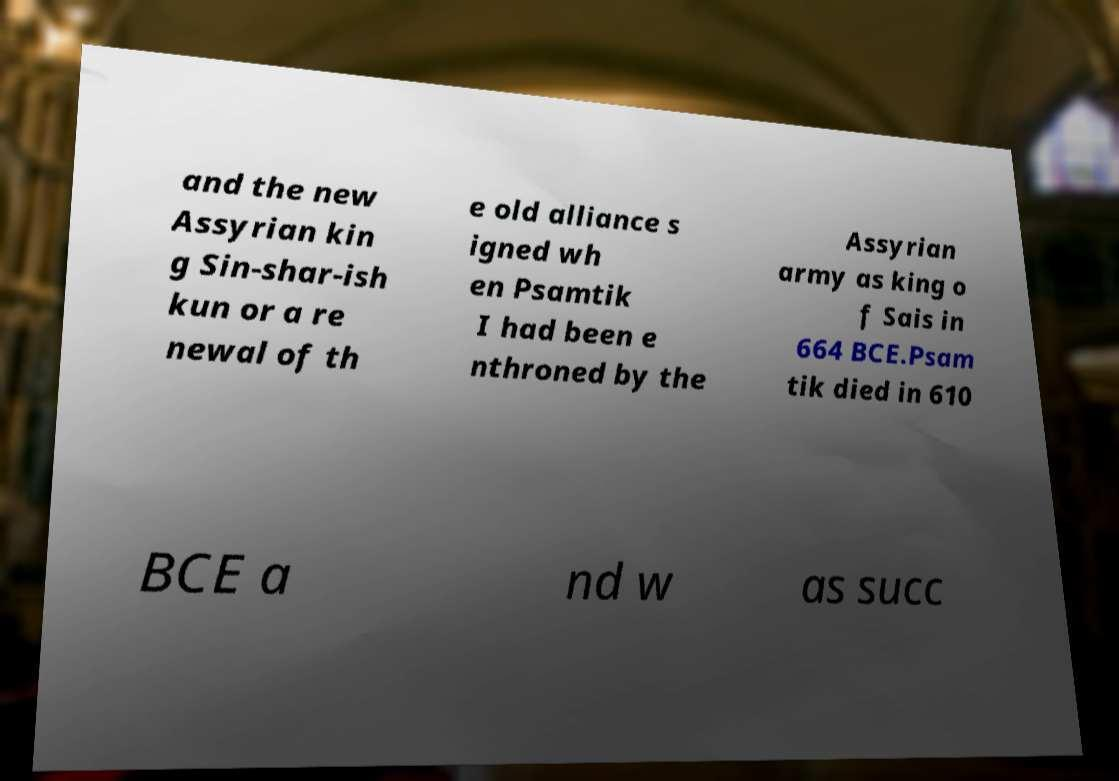Could you extract and type out the text from this image? and the new Assyrian kin g Sin-shar-ish kun or a re newal of th e old alliance s igned wh en Psamtik I had been e nthroned by the Assyrian army as king o f Sais in 664 BCE.Psam tik died in 610 BCE a nd w as succ 